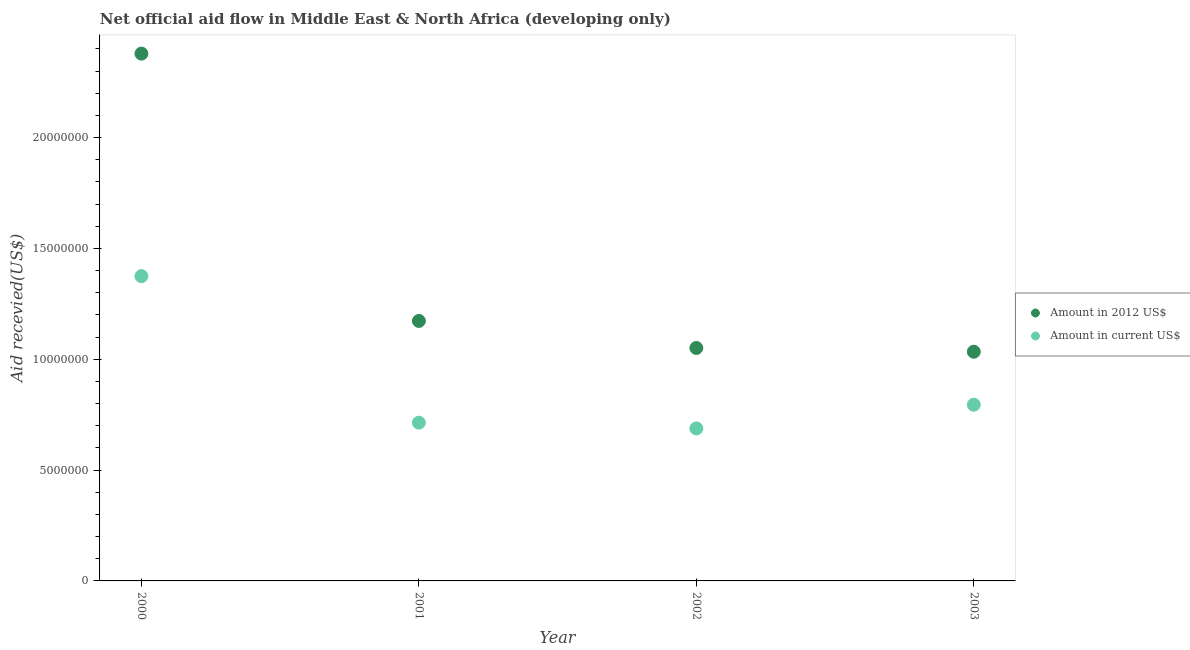How many different coloured dotlines are there?
Your answer should be very brief. 2. What is the amount of aid received(expressed in us$) in 2000?
Offer a terse response. 1.38e+07. Across all years, what is the maximum amount of aid received(expressed in 2012 us$)?
Your answer should be very brief. 2.38e+07. Across all years, what is the minimum amount of aid received(expressed in us$)?
Your answer should be very brief. 6.88e+06. In which year was the amount of aid received(expressed in us$) maximum?
Ensure brevity in your answer.  2000. What is the total amount of aid received(expressed in us$) in the graph?
Ensure brevity in your answer.  3.57e+07. What is the difference between the amount of aid received(expressed in 2012 us$) in 2001 and that in 2002?
Your response must be concise. 1.22e+06. What is the difference between the amount of aid received(expressed in us$) in 2002 and the amount of aid received(expressed in 2012 us$) in 2000?
Offer a terse response. -1.69e+07. What is the average amount of aid received(expressed in us$) per year?
Ensure brevity in your answer.  8.93e+06. In the year 2001, what is the difference between the amount of aid received(expressed in us$) and amount of aid received(expressed in 2012 us$)?
Offer a terse response. -4.59e+06. What is the ratio of the amount of aid received(expressed in us$) in 2000 to that in 2001?
Your answer should be very brief. 1.93. Is the amount of aid received(expressed in 2012 us$) in 2000 less than that in 2003?
Ensure brevity in your answer.  No. What is the difference between the highest and the second highest amount of aid received(expressed in us$)?
Offer a very short reply. 5.80e+06. What is the difference between the highest and the lowest amount of aid received(expressed in 2012 us$)?
Provide a short and direct response. 1.34e+07. In how many years, is the amount of aid received(expressed in 2012 us$) greater than the average amount of aid received(expressed in 2012 us$) taken over all years?
Offer a very short reply. 1. Is the sum of the amount of aid received(expressed in us$) in 2002 and 2003 greater than the maximum amount of aid received(expressed in 2012 us$) across all years?
Provide a succinct answer. No. Is the amount of aid received(expressed in 2012 us$) strictly greater than the amount of aid received(expressed in us$) over the years?
Provide a short and direct response. Yes. What is the difference between two consecutive major ticks on the Y-axis?
Keep it short and to the point. 5.00e+06. Does the graph contain grids?
Offer a very short reply. No. Where does the legend appear in the graph?
Provide a succinct answer. Center right. How many legend labels are there?
Your answer should be compact. 2. What is the title of the graph?
Provide a succinct answer. Net official aid flow in Middle East & North Africa (developing only). Does "Short-term debt" appear as one of the legend labels in the graph?
Your answer should be compact. No. What is the label or title of the X-axis?
Your answer should be compact. Year. What is the label or title of the Y-axis?
Offer a terse response. Aid recevied(US$). What is the Aid recevied(US$) of Amount in 2012 US$ in 2000?
Your answer should be compact. 2.38e+07. What is the Aid recevied(US$) in Amount in current US$ in 2000?
Your answer should be very brief. 1.38e+07. What is the Aid recevied(US$) of Amount in 2012 US$ in 2001?
Ensure brevity in your answer.  1.17e+07. What is the Aid recevied(US$) in Amount in current US$ in 2001?
Make the answer very short. 7.14e+06. What is the Aid recevied(US$) in Amount in 2012 US$ in 2002?
Ensure brevity in your answer.  1.05e+07. What is the Aid recevied(US$) of Amount in current US$ in 2002?
Offer a very short reply. 6.88e+06. What is the Aid recevied(US$) in Amount in 2012 US$ in 2003?
Your answer should be very brief. 1.03e+07. What is the Aid recevied(US$) of Amount in current US$ in 2003?
Your answer should be compact. 7.95e+06. Across all years, what is the maximum Aid recevied(US$) of Amount in 2012 US$?
Give a very brief answer. 2.38e+07. Across all years, what is the maximum Aid recevied(US$) of Amount in current US$?
Provide a succinct answer. 1.38e+07. Across all years, what is the minimum Aid recevied(US$) in Amount in 2012 US$?
Your answer should be very brief. 1.03e+07. Across all years, what is the minimum Aid recevied(US$) of Amount in current US$?
Your response must be concise. 6.88e+06. What is the total Aid recevied(US$) of Amount in 2012 US$ in the graph?
Ensure brevity in your answer.  5.64e+07. What is the total Aid recevied(US$) in Amount in current US$ in the graph?
Offer a terse response. 3.57e+07. What is the difference between the Aid recevied(US$) of Amount in 2012 US$ in 2000 and that in 2001?
Offer a very short reply. 1.21e+07. What is the difference between the Aid recevied(US$) of Amount in current US$ in 2000 and that in 2001?
Offer a terse response. 6.61e+06. What is the difference between the Aid recevied(US$) of Amount in 2012 US$ in 2000 and that in 2002?
Give a very brief answer. 1.33e+07. What is the difference between the Aid recevied(US$) in Amount in current US$ in 2000 and that in 2002?
Provide a succinct answer. 6.87e+06. What is the difference between the Aid recevied(US$) in Amount in 2012 US$ in 2000 and that in 2003?
Keep it short and to the point. 1.34e+07. What is the difference between the Aid recevied(US$) of Amount in current US$ in 2000 and that in 2003?
Your answer should be very brief. 5.80e+06. What is the difference between the Aid recevied(US$) in Amount in 2012 US$ in 2001 and that in 2002?
Keep it short and to the point. 1.22e+06. What is the difference between the Aid recevied(US$) of Amount in 2012 US$ in 2001 and that in 2003?
Your answer should be very brief. 1.39e+06. What is the difference between the Aid recevied(US$) of Amount in current US$ in 2001 and that in 2003?
Your answer should be very brief. -8.10e+05. What is the difference between the Aid recevied(US$) of Amount in current US$ in 2002 and that in 2003?
Keep it short and to the point. -1.07e+06. What is the difference between the Aid recevied(US$) in Amount in 2012 US$ in 2000 and the Aid recevied(US$) in Amount in current US$ in 2001?
Your answer should be compact. 1.66e+07. What is the difference between the Aid recevied(US$) in Amount in 2012 US$ in 2000 and the Aid recevied(US$) in Amount in current US$ in 2002?
Provide a short and direct response. 1.69e+07. What is the difference between the Aid recevied(US$) in Amount in 2012 US$ in 2000 and the Aid recevied(US$) in Amount in current US$ in 2003?
Ensure brevity in your answer.  1.58e+07. What is the difference between the Aid recevied(US$) in Amount in 2012 US$ in 2001 and the Aid recevied(US$) in Amount in current US$ in 2002?
Give a very brief answer. 4.85e+06. What is the difference between the Aid recevied(US$) of Amount in 2012 US$ in 2001 and the Aid recevied(US$) of Amount in current US$ in 2003?
Provide a succinct answer. 3.78e+06. What is the difference between the Aid recevied(US$) in Amount in 2012 US$ in 2002 and the Aid recevied(US$) in Amount in current US$ in 2003?
Offer a very short reply. 2.56e+06. What is the average Aid recevied(US$) of Amount in 2012 US$ per year?
Offer a terse response. 1.41e+07. What is the average Aid recevied(US$) of Amount in current US$ per year?
Your answer should be very brief. 8.93e+06. In the year 2000, what is the difference between the Aid recevied(US$) in Amount in 2012 US$ and Aid recevied(US$) in Amount in current US$?
Make the answer very short. 1.00e+07. In the year 2001, what is the difference between the Aid recevied(US$) of Amount in 2012 US$ and Aid recevied(US$) of Amount in current US$?
Offer a terse response. 4.59e+06. In the year 2002, what is the difference between the Aid recevied(US$) of Amount in 2012 US$ and Aid recevied(US$) of Amount in current US$?
Provide a succinct answer. 3.63e+06. In the year 2003, what is the difference between the Aid recevied(US$) in Amount in 2012 US$ and Aid recevied(US$) in Amount in current US$?
Ensure brevity in your answer.  2.39e+06. What is the ratio of the Aid recevied(US$) of Amount in 2012 US$ in 2000 to that in 2001?
Your response must be concise. 2.03. What is the ratio of the Aid recevied(US$) in Amount in current US$ in 2000 to that in 2001?
Your answer should be compact. 1.93. What is the ratio of the Aid recevied(US$) in Amount in 2012 US$ in 2000 to that in 2002?
Offer a terse response. 2.26. What is the ratio of the Aid recevied(US$) of Amount in current US$ in 2000 to that in 2002?
Make the answer very short. 2. What is the ratio of the Aid recevied(US$) of Amount in 2012 US$ in 2000 to that in 2003?
Make the answer very short. 2.3. What is the ratio of the Aid recevied(US$) in Amount in current US$ in 2000 to that in 2003?
Give a very brief answer. 1.73. What is the ratio of the Aid recevied(US$) of Amount in 2012 US$ in 2001 to that in 2002?
Provide a succinct answer. 1.12. What is the ratio of the Aid recevied(US$) in Amount in current US$ in 2001 to that in 2002?
Give a very brief answer. 1.04. What is the ratio of the Aid recevied(US$) in Amount in 2012 US$ in 2001 to that in 2003?
Your answer should be very brief. 1.13. What is the ratio of the Aid recevied(US$) in Amount in current US$ in 2001 to that in 2003?
Your answer should be very brief. 0.9. What is the ratio of the Aid recevied(US$) in Amount in 2012 US$ in 2002 to that in 2003?
Ensure brevity in your answer.  1.02. What is the ratio of the Aid recevied(US$) of Amount in current US$ in 2002 to that in 2003?
Offer a very short reply. 0.87. What is the difference between the highest and the second highest Aid recevied(US$) of Amount in 2012 US$?
Provide a succinct answer. 1.21e+07. What is the difference between the highest and the second highest Aid recevied(US$) in Amount in current US$?
Offer a very short reply. 5.80e+06. What is the difference between the highest and the lowest Aid recevied(US$) in Amount in 2012 US$?
Offer a terse response. 1.34e+07. What is the difference between the highest and the lowest Aid recevied(US$) of Amount in current US$?
Provide a succinct answer. 6.87e+06. 